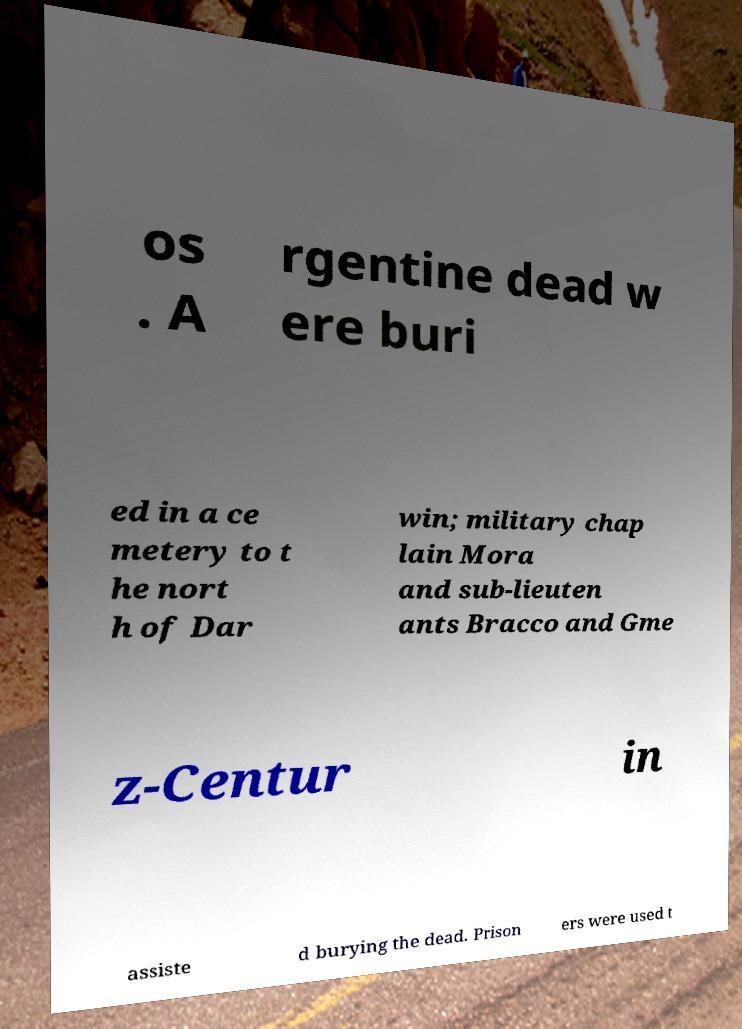There's text embedded in this image that I need extracted. Can you transcribe it verbatim? os . A rgentine dead w ere buri ed in a ce metery to t he nort h of Dar win; military chap lain Mora and sub-lieuten ants Bracco and Gme z-Centur in assiste d burying the dead. Prison ers were used t 